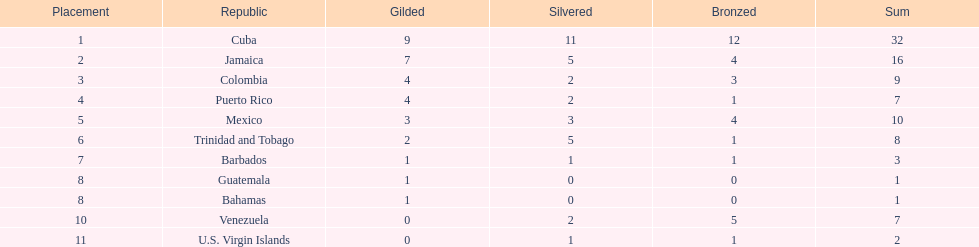What is the total number of gold medals awarded between these 11 countries? 32. 